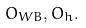<formula> <loc_0><loc_0><loc_500><loc_500>O _ { W B } , O _ { h } .</formula> 